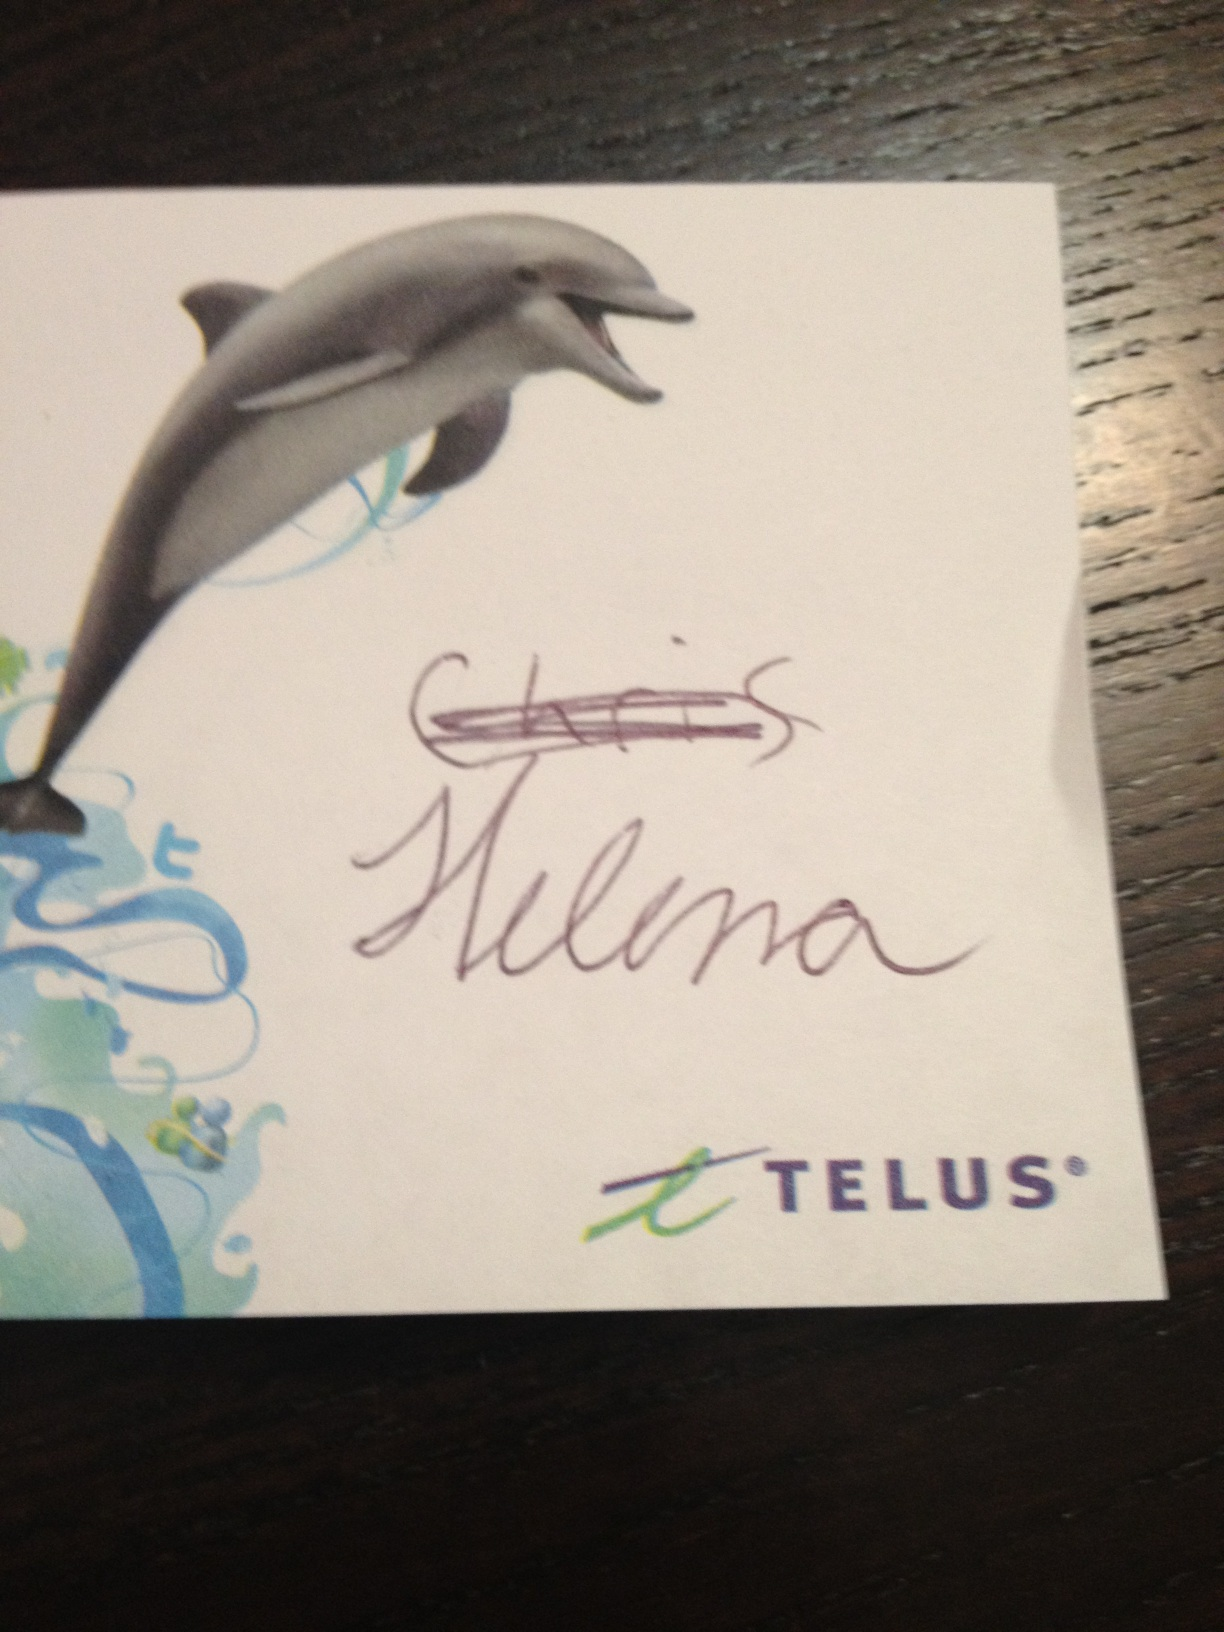Why might the name 'Chris Helena' be featured on this card? The names 'Chris Helena' might represent individuals who were either recipients of this card as part of a promotion or possibly employees or representatives associated with the Telus brand. The specific personalization suggests a direct engagement or appreciation gesture. 